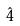<formula> <loc_0><loc_0><loc_500><loc_500>\hat { 4 }</formula> 